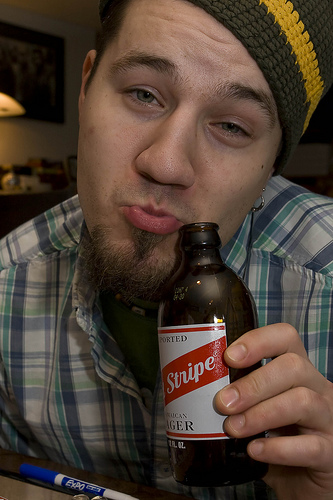<image>
Is there a bottle in front of the man? Yes. The bottle is positioned in front of the man, appearing closer to the camera viewpoint. Is the marker in front of the picture? Yes. The marker is positioned in front of the picture, appearing closer to the camera viewpoint. Is there a man in front of the beer? No. The man is not in front of the beer. The spatial positioning shows a different relationship between these objects. 